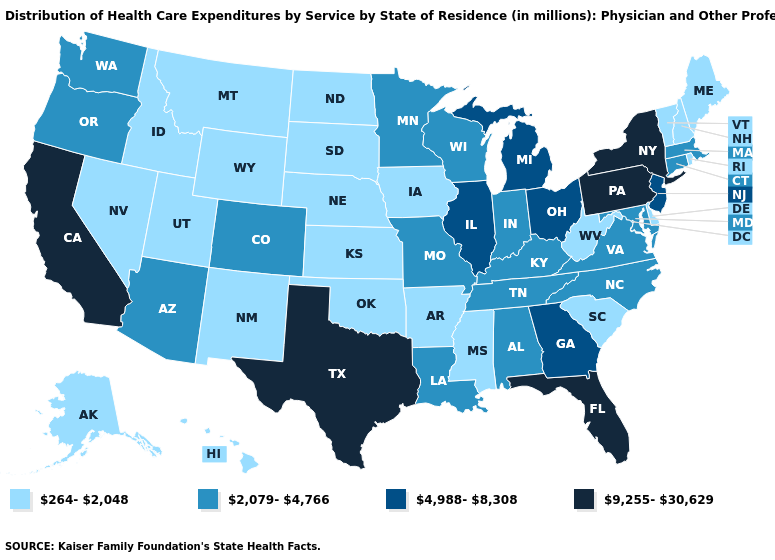Does Connecticut have the same value as Virginia?
Quick response, please. Yes. Name the states that have a value in the range 9,255-30,629?
Concise answer only. California, Florida, New York, Pennsylvania, Texas. What is the value of New York?
Write a very short answer. 9,255-30,629. What is the value of Kentucky?
Concise answer only. 2,079-4,766. What is the highest value in states that border Montana?
Be succinct. 264-2,048. What is the value of Tennessee?
Give a very brief answer. 2,079-4,766. How many symbols are there in the legend?
Short answer required. 4. What is the lowest value in states that border Maine?
Give a very brief answer. 264-2,048. What is the value of Kentucky?
Concise answer only. 2,079-4,766. Does Missouri have the lowest value in the USA?
Short answer required. No. Name the states that have a value in the range 9,255-30,629?
Give a very brief answer. California, Florida, New York, Pennsylvania, Texas. Does Kansas have a higher value than Vermont?
Answer briefly. No. What is the value of Wisconsin?
Give a very brief answer. 2,079-4,766. Name the states that have a value in the range 4,988-8,308?
Write a very short answer. Georgia, Illinois, Michigan, New Jersey, Ohio. Does the first symbol in the legend represent the smallest category?
Short answer required. Yes. 